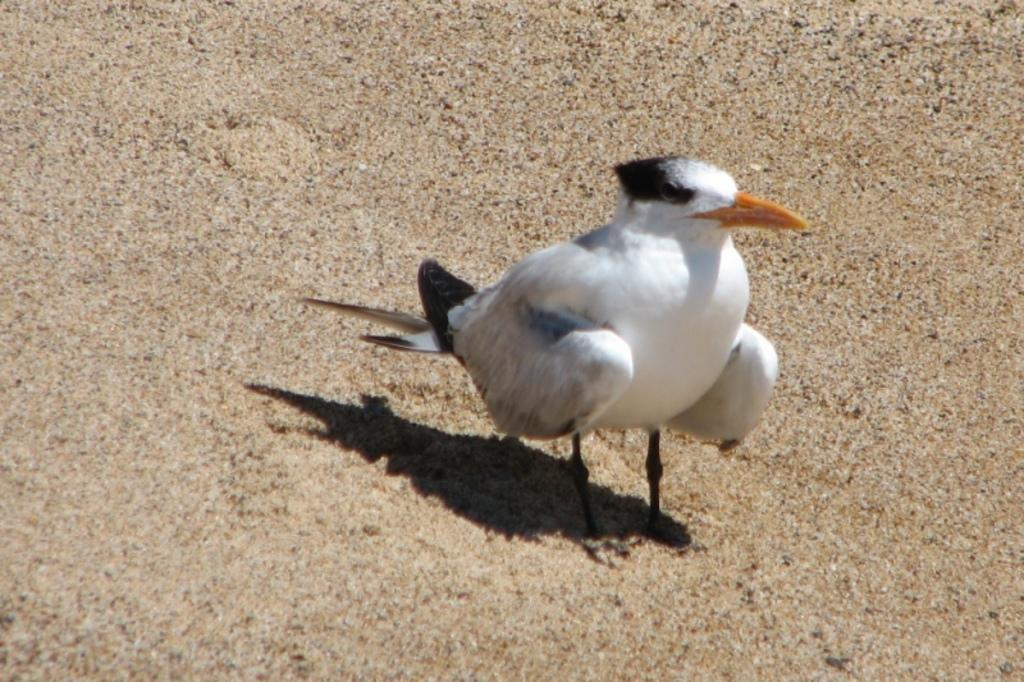What type of animal can be seen in the image? There is a bird in the image. Where is the bird located? The bird is standing on the land. What color is the sweater that the bird is wearing in the image? There is no sweater present in the image, and the bird is not wearing any clothing. 